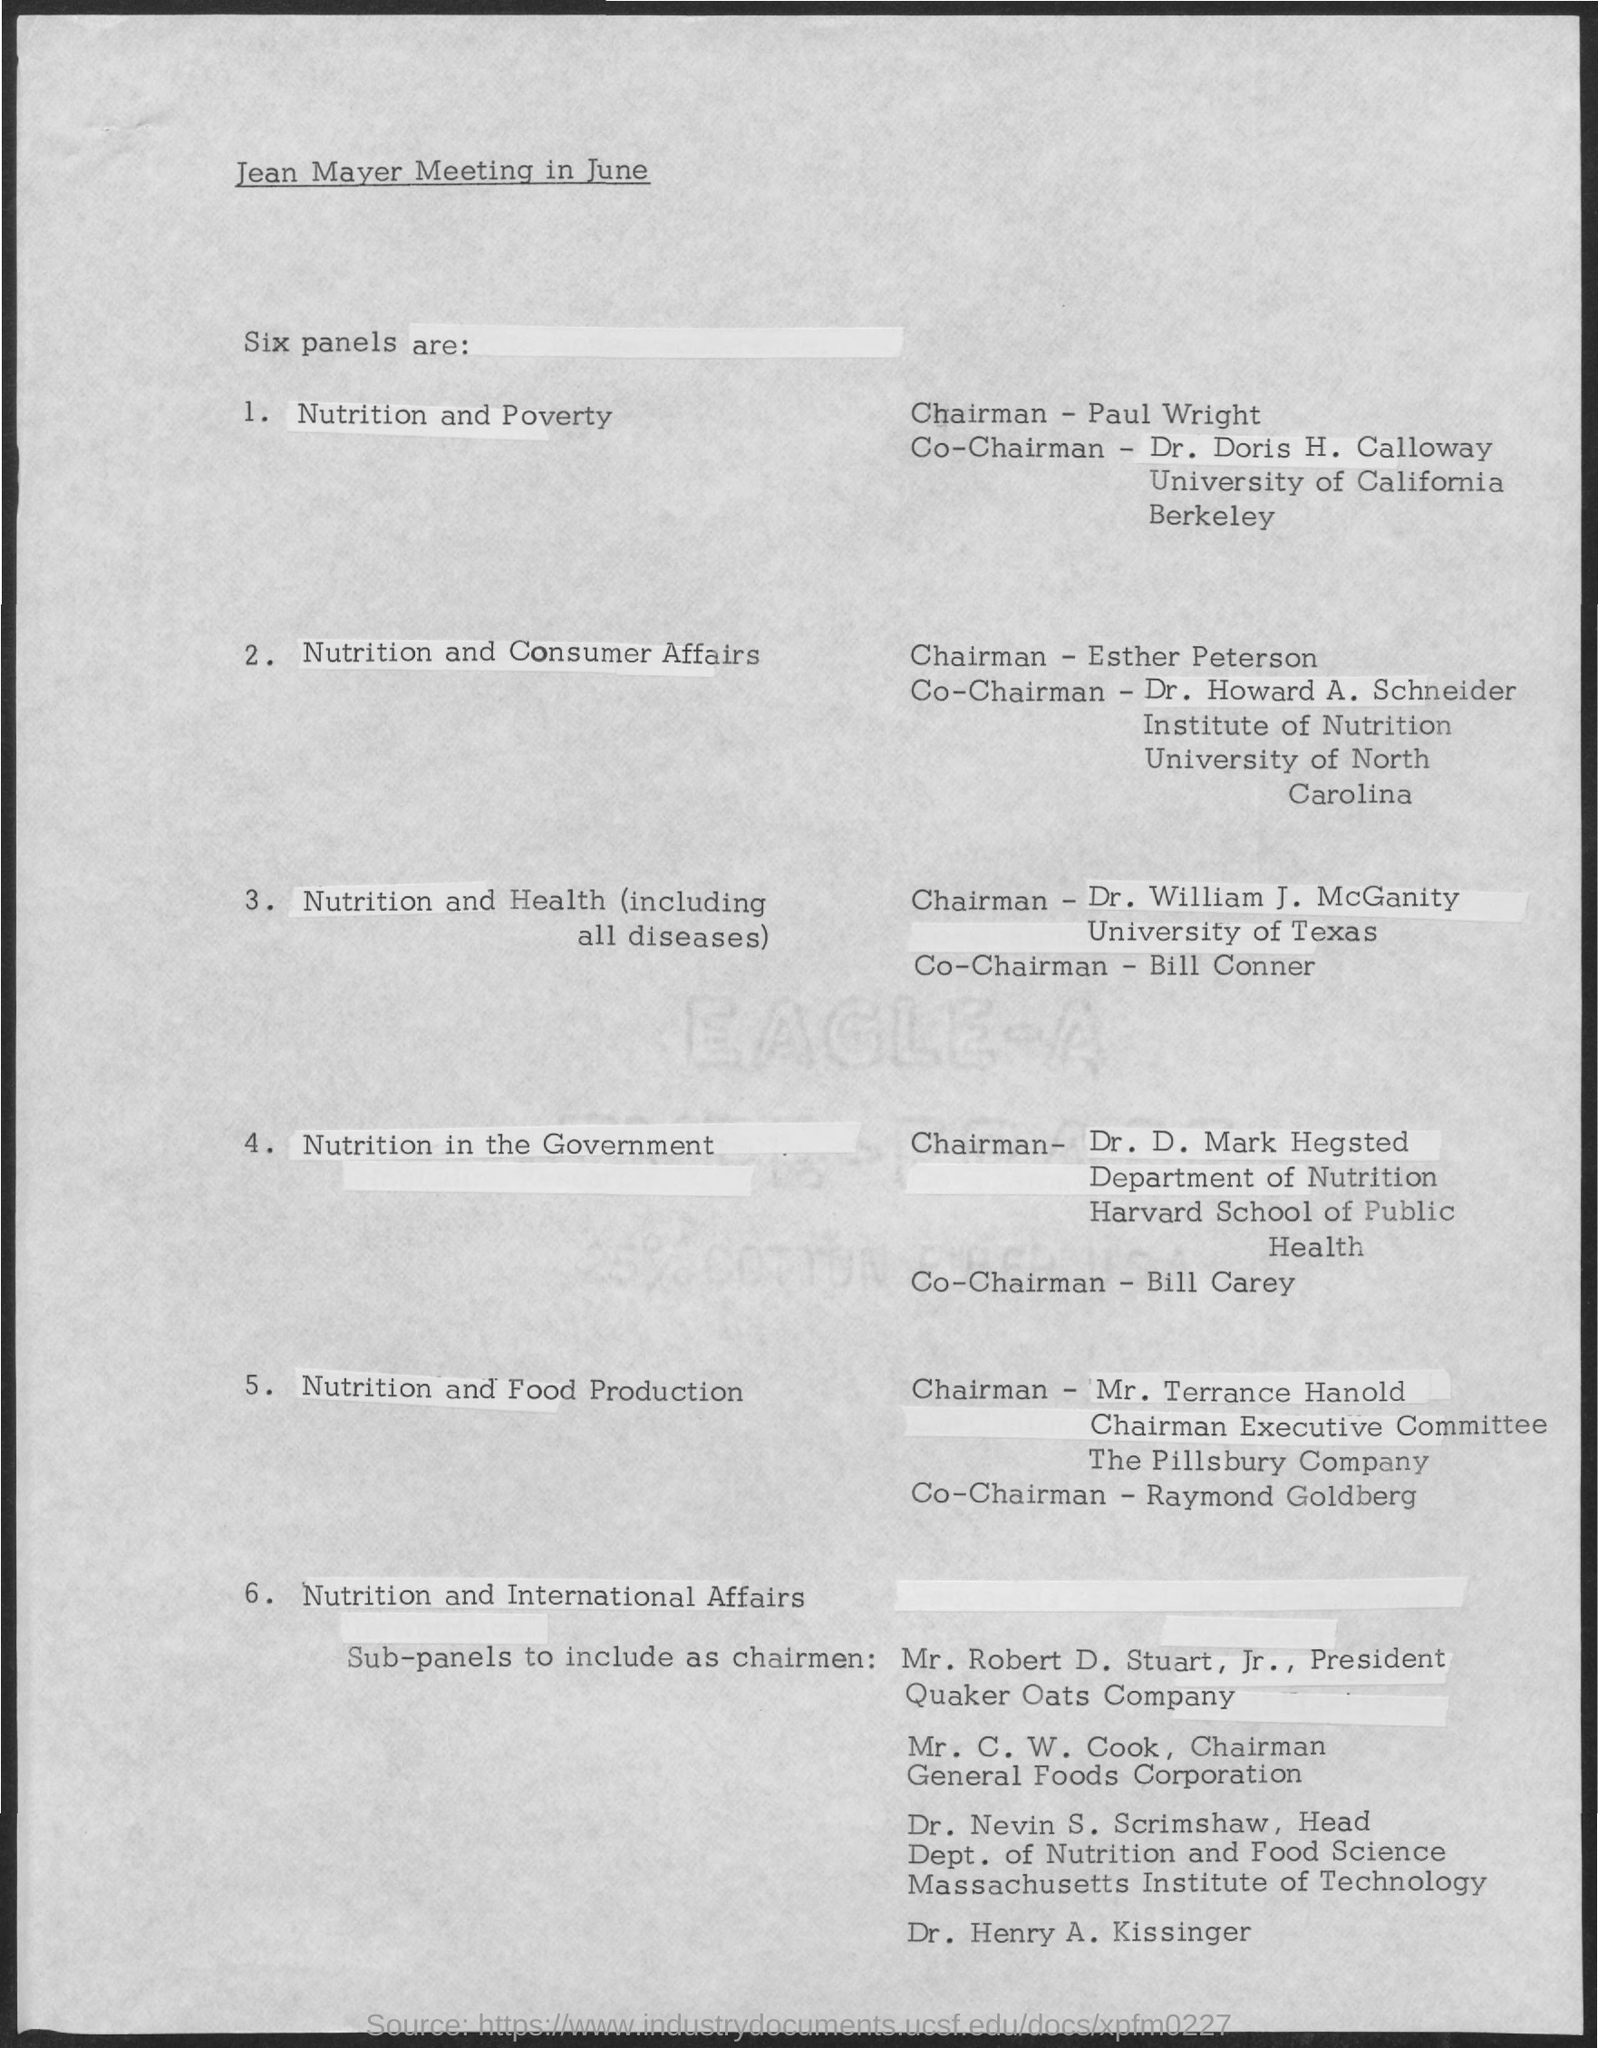What is the first title in the document?
Keep it short and to the point. Jean Mayer Meeting in June. Who is the chairman of the nutrition and poverty panel?
Give a very brief answer. Paul wright. Who is the chairman of the nutrition and consumer affairs panel?
Your answer should be very brief. Esther peterson. Who is the co-chairman of the nutrition and health panel?
Keep it short and to the point. Bill conner. Who is the co-chairman of the nutrition and food production panel?
Ensure brevity in your answer.  Raymond goldberg. Who is the co-chairman of the nutrition in the government panel?
Give a very brief answer. Bill carey. 